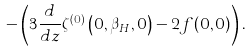Convert formula to latex. <formula><loc_0><loc_0><loc_500><loc_500>- \left ( 3 { \frac { d } { d z } } \zeta ^ { ( 0 ) } \left ( 0 , \beta _ { H } , 0 \right ) - 2 f ( 0 , 0 ) \right ) .</formula> 